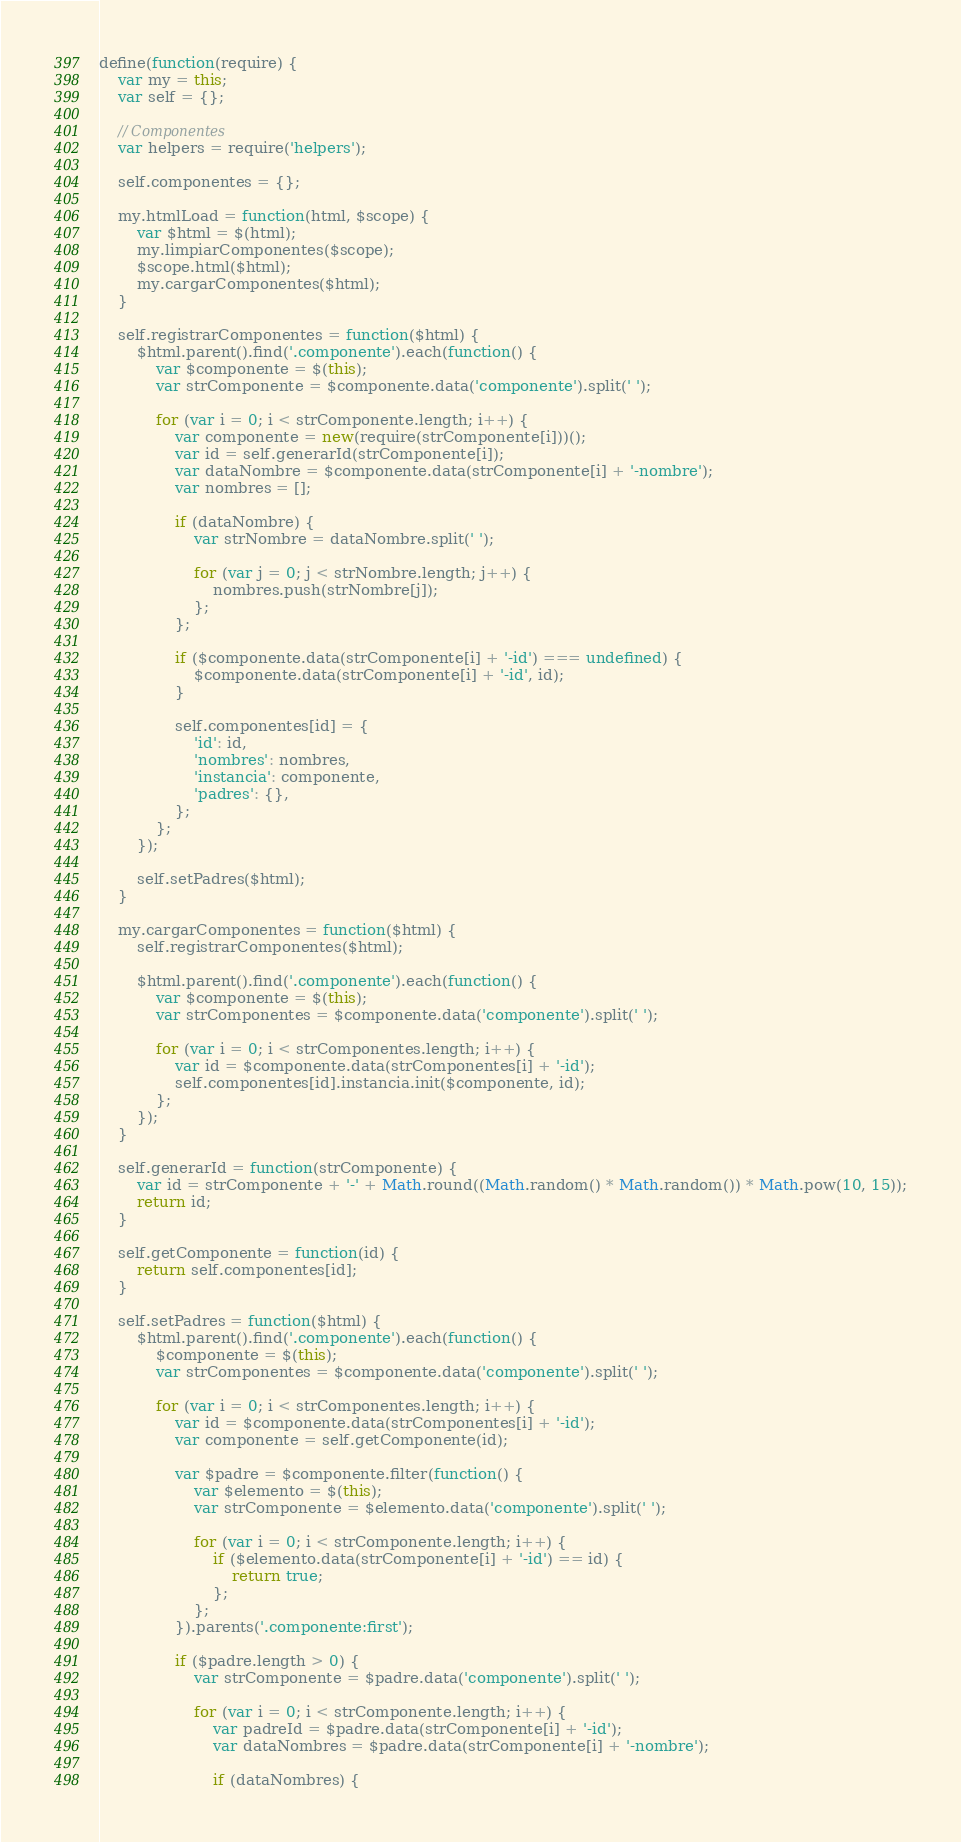<code> <loc_0><loc_0><loc_500><loc_500><_JavaScript_>define(function(require) {
	var my = this;
	var self = {};

	// Componentes
	var helpers = require('helpers');

	self.componentes = {};

	my.htmlLoad = function(html, $scope) {
		var $html = $(html);
		my.limpiarComponentes($scope);
		$scope.html($html);
		my.cargarComponentes($html);
	}

	self.registrarComponentes = function($html) {
		$html.parent().find('.componente').each(function() {
			var $componente = $(this);
			var strComponente = $componente.data('componente').split(' ');

			for (var i = 0; i < strComponente.length; i++) {
				var componente = new(require(strComponente[i]))();
				var id = self.generarId(strComponente[i]);
				var dataNombre = $componente.data(strComponente[i] + '-nombre');
				var nombres = [];

				if (dataNombre) {
					var strNombre = dataNombre.split(' ');

					for (var j = 0; j < strNombre.length; j++) {
						nombres.push(strNombre[j]);
					};
				};

				if ($componente.data(strComponente[i] + '-id') === undefined) {
					$componente.data(strComponente[i] + '-id', id);
				}

				self.componentes[id] = {
					'id': id,
					'nombres': nombres,
					'instancia': componente,
					'padres': {},
				};
			};
		});

		self.setPadres($html);
	}

	my.cargarComponentes = function($html) {
		self.registrarComponentes($html);

		$html.parent().find('.componente').each(function() {
			var $componente = $(this);
			var strComponentes = $componente.data('componente').split(' ');

			for (var i = 0; i < strComponentes.length; i++) {
				var id = $componente.data(strComponentes[i] + '-id');
				self.componentes[id].instancia.init($componente, id);
			};
		});
	}

	self.generarId = function(strComponente) {
		var id = strComponente + '-' + Math.round((Math.random() * Math.random()) * Math.pow(10, 15));
		return id;
	}

	self.getComponente = function(id) {
		return self.componentes[id];
	}

	self.setPadres = function($html) {
		$html.parent().find('.componente').each(function() {
			$componente = $(this);
			var strComponentes = $componente.data('componente').split(' ');

			for (var i = 0; i < strComponentes.length; i++) {
				var id = $componente.data(strComponentes[i] + '-id');
				var componente = self.getComponente(id);

				var $padre = $componente.filter(function() {
					var $elemento = $(this);
					var strComponente = $elemento.data('componente').split(' ');

					for (var i = 0; i < strComponente.length; i++) {
						if ($elemento.data(strComponente[i] + '-id') == id) {
							return true;
						};
					};
				}).parents('.componente:first');

				if ($padre.length > 0) {
					var strComponente = $padre.data('componente').split(' ');

					for (var i = 0; i < strComponente.length; i++) {
						var padreId = $padre.data(strComponente[i] + '-id');
						var dataNombres = $padre.data(strComponente[i] + '-nombre');

						if (dataNombres) {</code> 